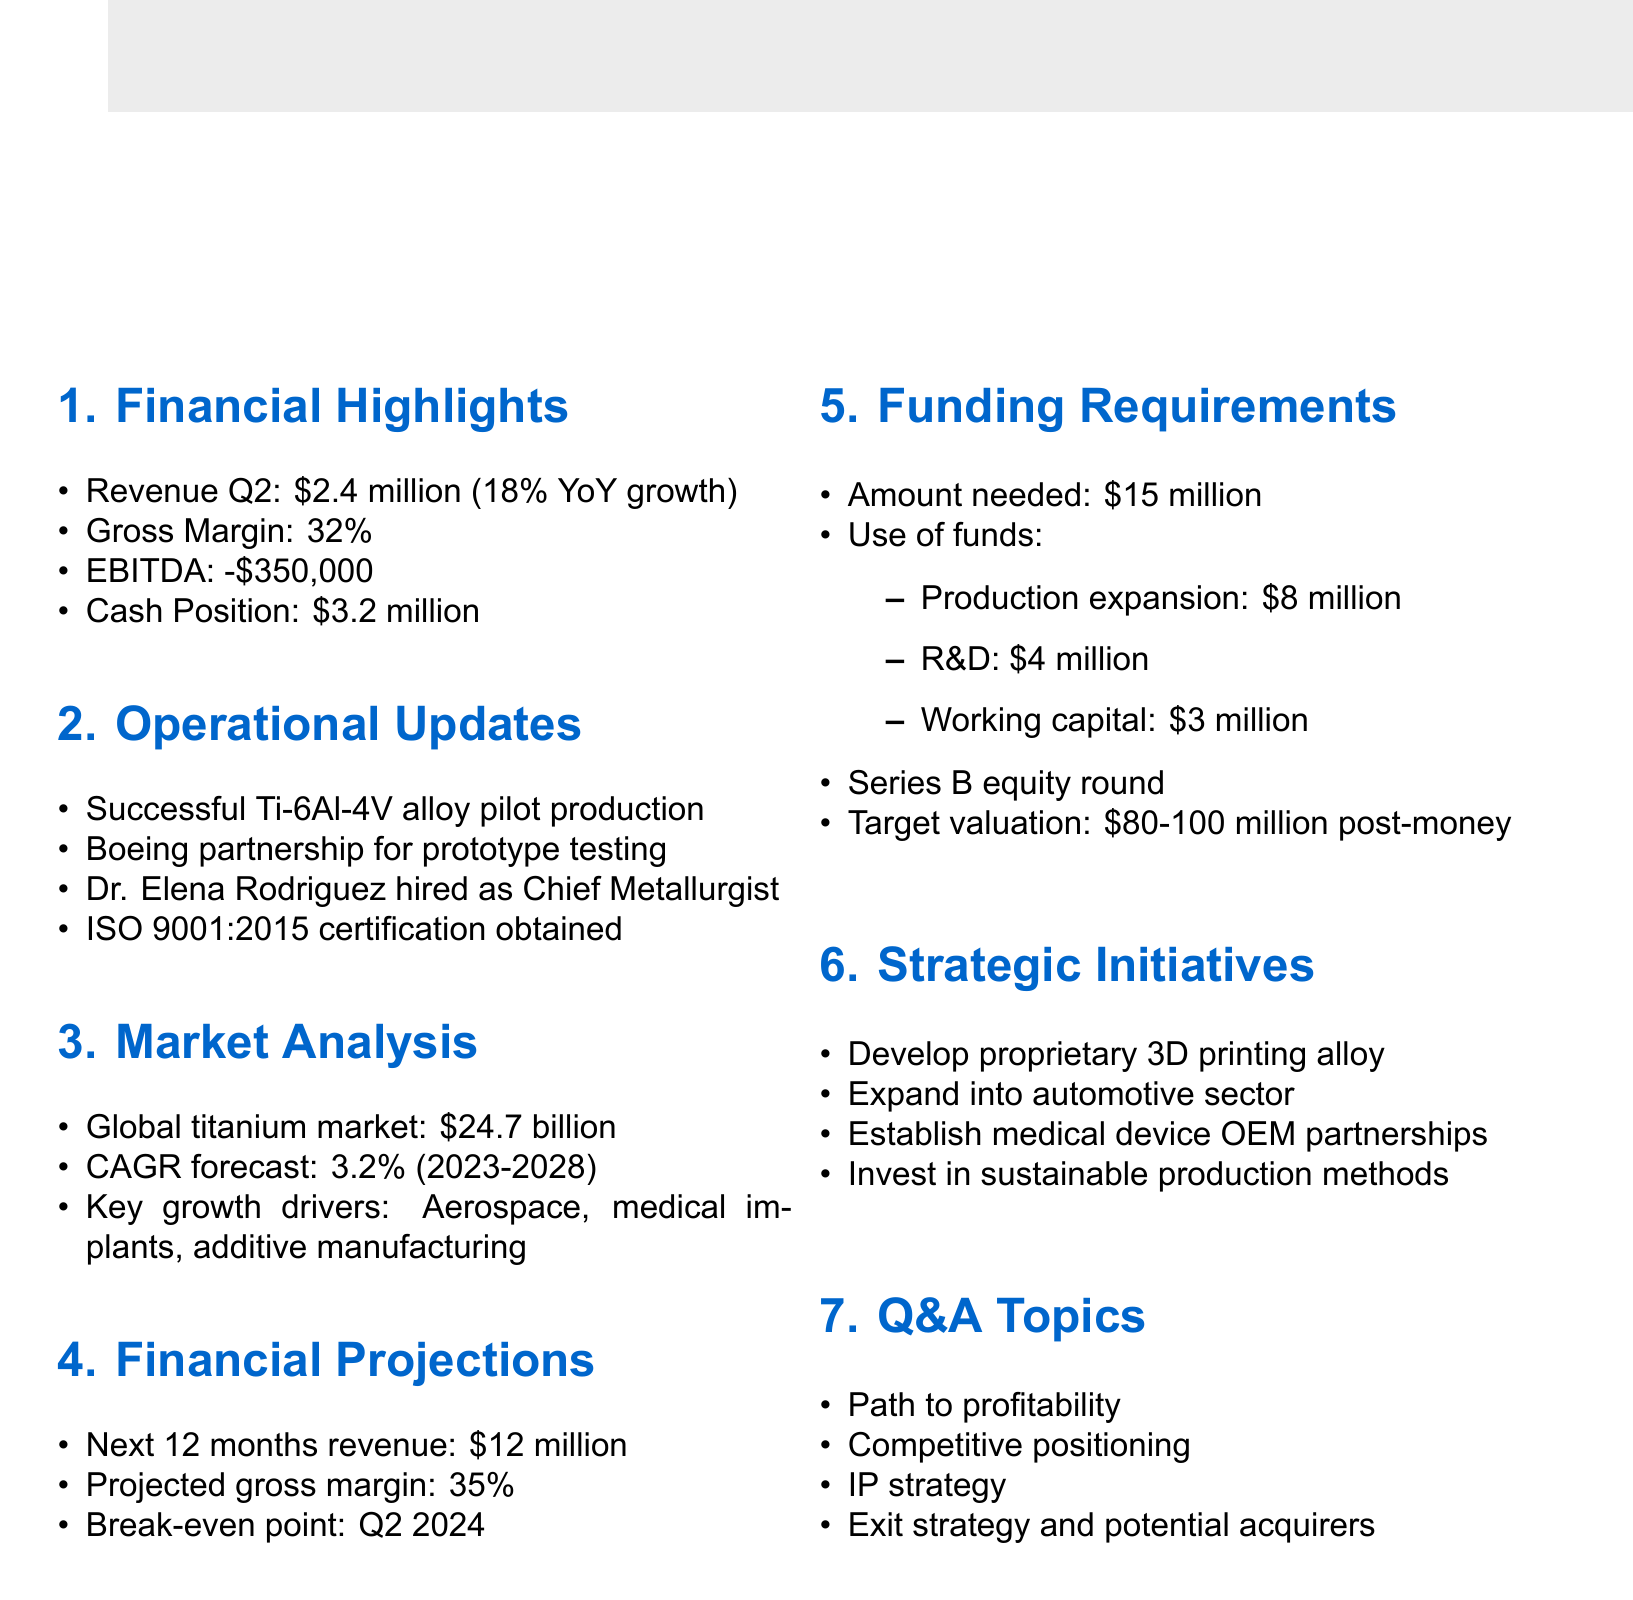What is the company name? The company name is mentioned in the document under meeting details.
Answer: TitanTech Alloys What is the date of the meeting? The date is specified in the meeting details section of the document.
Answer: June 15, 2023 What was the revenue for Q2? The revenue figure for Q2 is highlighted in the financial highlights part of the document.
Answer: $2.4 million What is the projected gross margin? The projected gross margin is included in the financial projections section of the document.
Answer: 35% How much funding is needed? The amount needed for funding is stated in the funding requirements section.
Answer: $15 million What is the key assumption for the financial projections? Key assumptions for projections are listed in the financial projections section of the document.
Answer: Successful scale-up of production capacity What is the expected break-even point? The expected break-even point is mentioned in the financial projections section.
Answer: Q2 2024 Who was hired as Chief Metallurgist? The hiring of the Chief Metallurgist is noted in the operational updates section.
Answer: Dr. Elena Rodriguez What is the target valuation post-money? The post-money valuation is stated under funding requirements.
Answer: $80-100 million 